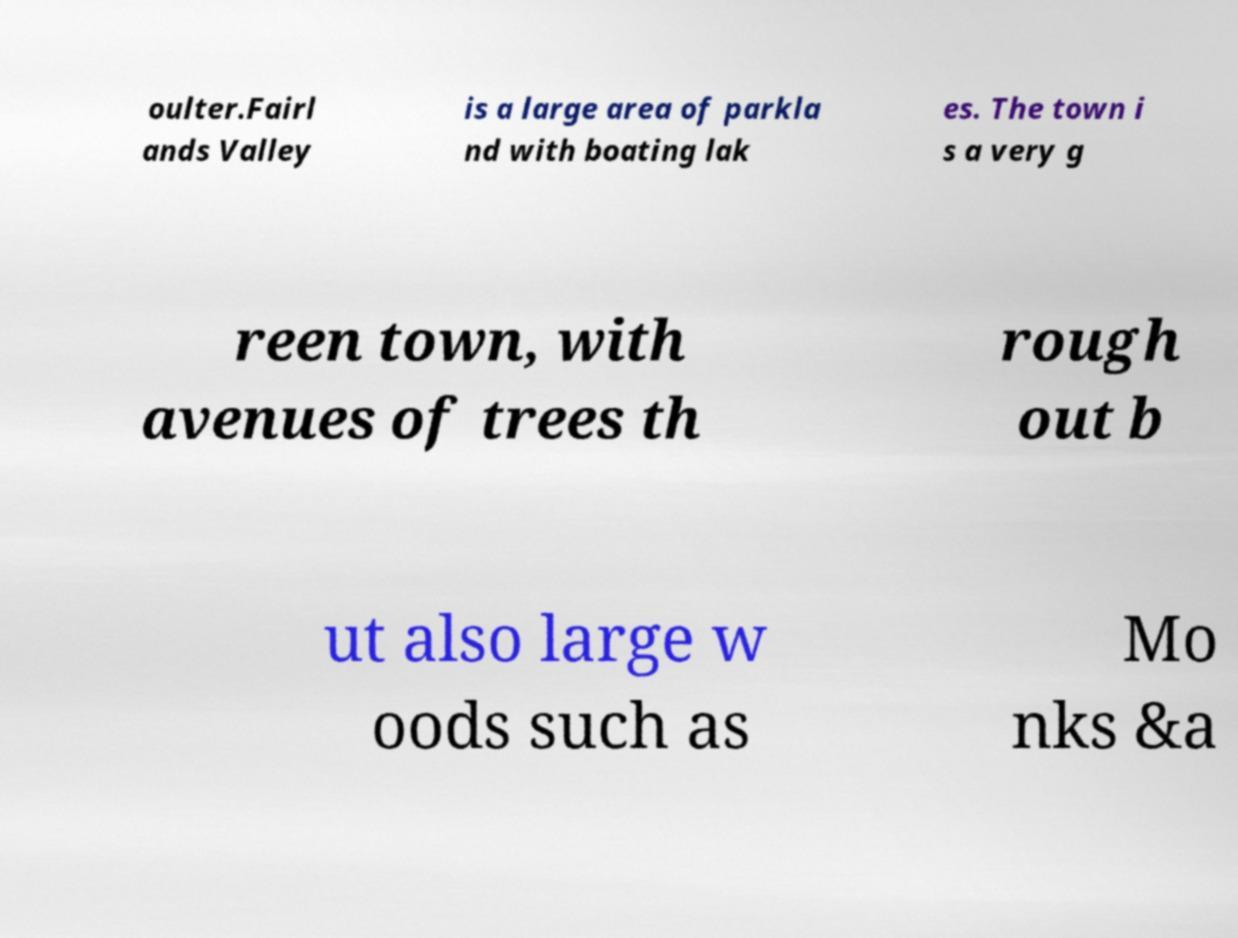What messages or text are displayed in this image? I need them in a readable, typed format. oulter.Fairl ands Valley is a large area of parkla nd with boating lak es. The town i s a very g reen town, with avenues of trees th rough out b ut also large w oods such as Mo nks &a 